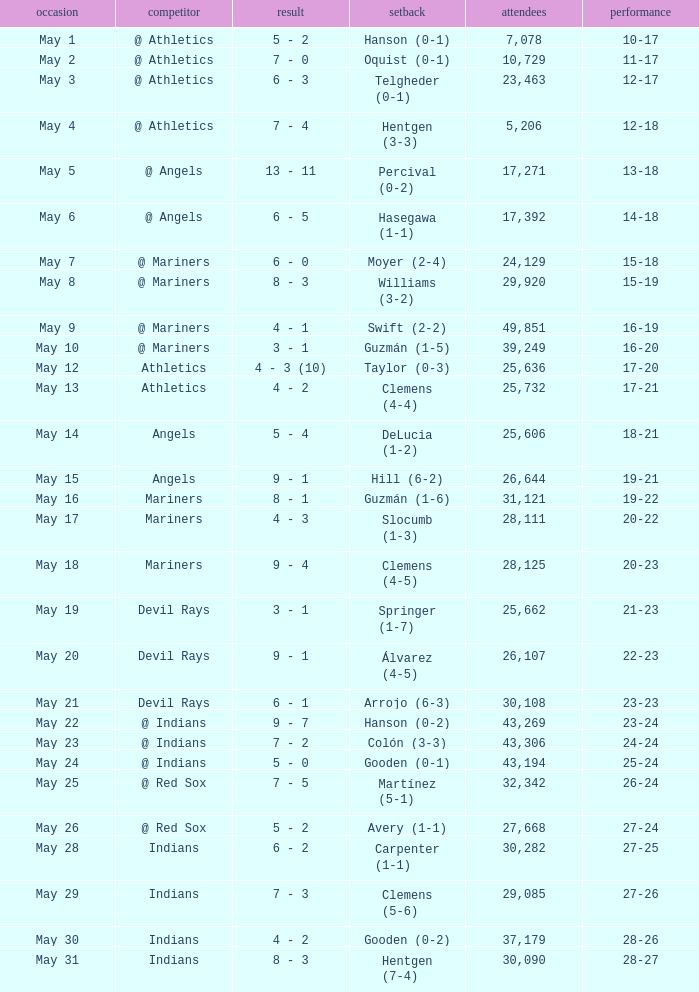What is the record for May 31? 28-27. 